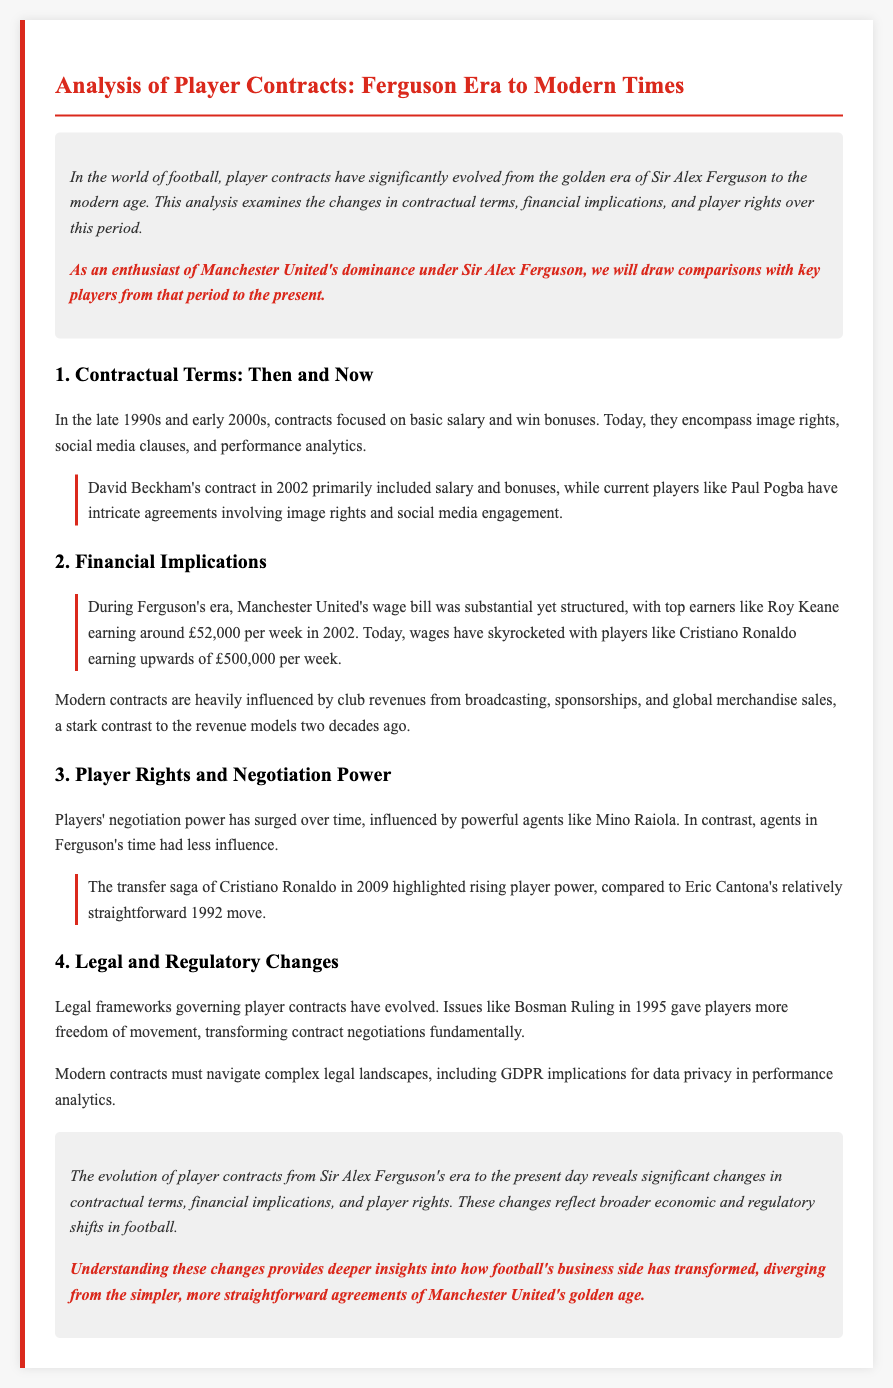What was a primary focus of contracts in Ferguson's era? Contracts in Ferguson's era focused on basic salary and win bonuses.
Answer: Basic salary and win bonuses What is an example of a player from Ferguson's era? One example of a player from Ferguson's era mentioned in the document is Eric Cantona.
Answer: Eric Cantona What significant change in player wages is highlighted? The document highlights that wages have skyrocketed from £52,000 per week in 2002 to upwards of £500,000 per week today.
Answer: £500,000 per week What ruling gave players more freedom of movement? The Bosman Ruling in 1995 is mentioned as a significant ruling that gave players more freedom of movement.
Answer: Bosman Ruling Who is an example of a powerful modern agent? Mino Raiola is cited as an example of a powerful modern agent influencing player negotiations.
Answer: Mino Raiola What were contracts primarily focused on during Ferguson's era compared to now? Contracts during Ferguson's era were mainly focused on salary and bonuses, while modern contracts include image rights and social media clauses.
Answer: Salary and bonuses; image rights and social media clauses What issue must modern contracts navigate that was not as relevant in the past? Modern contracts must navigate complex legal landscapes, including GDPR implications for data privacy.
Answer: GDPR implications for data privacy What financial changes reflect broader shifts in football's business side? The significant increase in player wages and the complexity of contracts reflect broader economic shifts.
Answer: Increase in player wages; complexity of contracts What historical period does this analysis compare player contracts from? The analysis compares player contracts from Sir Alex Ferguson's era to modern times.
Answer: Sir Alex Ferguson's era to modern times 